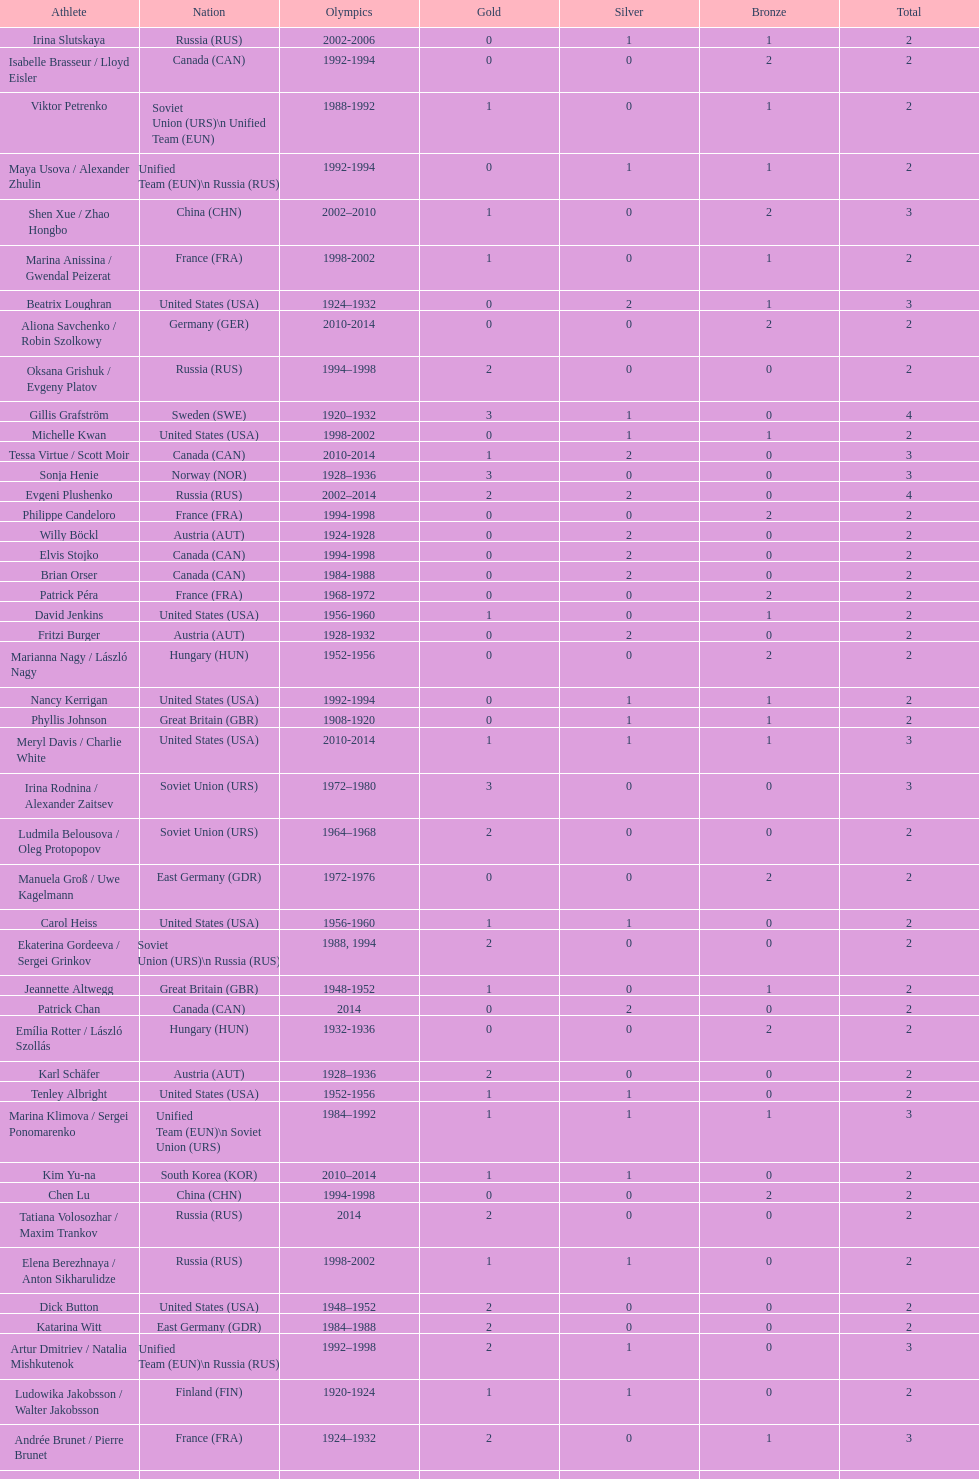Which athlete was from south korea after the year 2010? Kim Yu-na. 